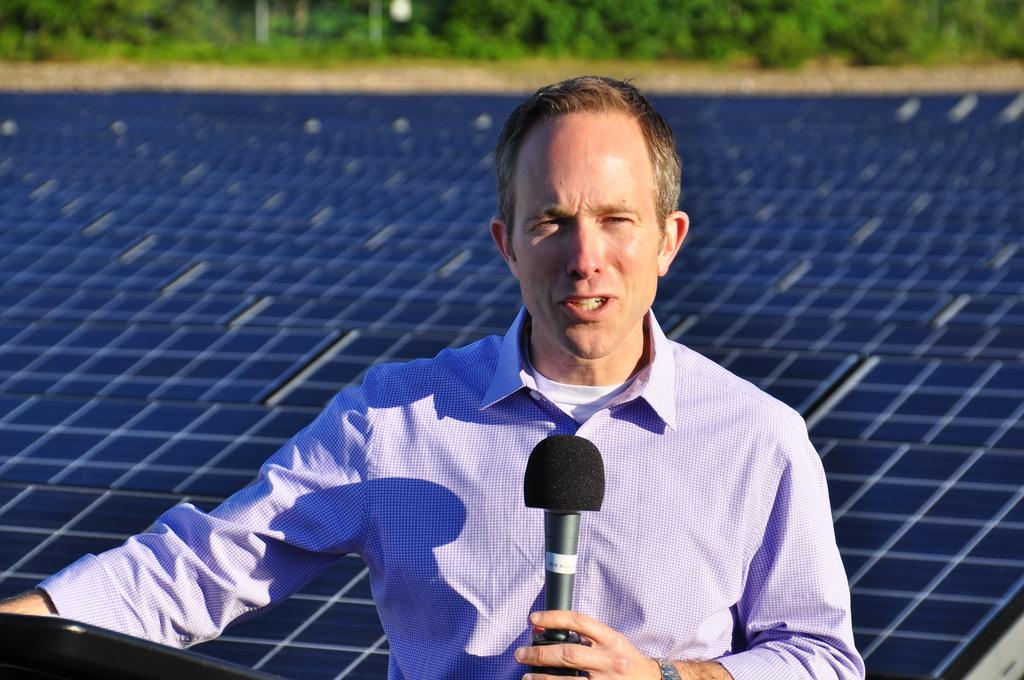What can be seen in the background of the image? There are plants in the background of the image. Who is present in the image? There is a man in the image. What is the man holding in his hand? The man is holding a microphone in his hand. What is the man doing in the image? The man is talking. What is the weather like in the image? The day appears to be sunny. Can you tell me where the nearest hospital is in the image? There is no information about a hospital in the image; it only shows a man holding a microphone and talking. How many friends can be seen in the image? There is no mention of friends in the image; it only features a man holding a microphone. 